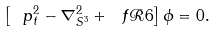<formula> <loc_0><loc_0><loc_500><loc_500>\left [ \ p _ { t } ^ { 2 } - \nabla _ { S ^ { 3 } } ^ { 2 } + \ f { \mathcal { R } } { 6 } \right ] \phi = 0 .</formula> 